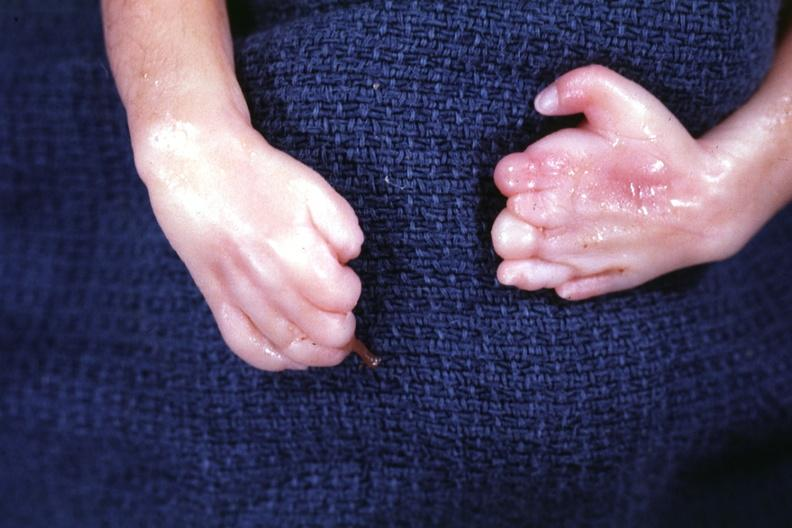what deformed fingers?
Answer the question using a single word or phrase. Both hands 